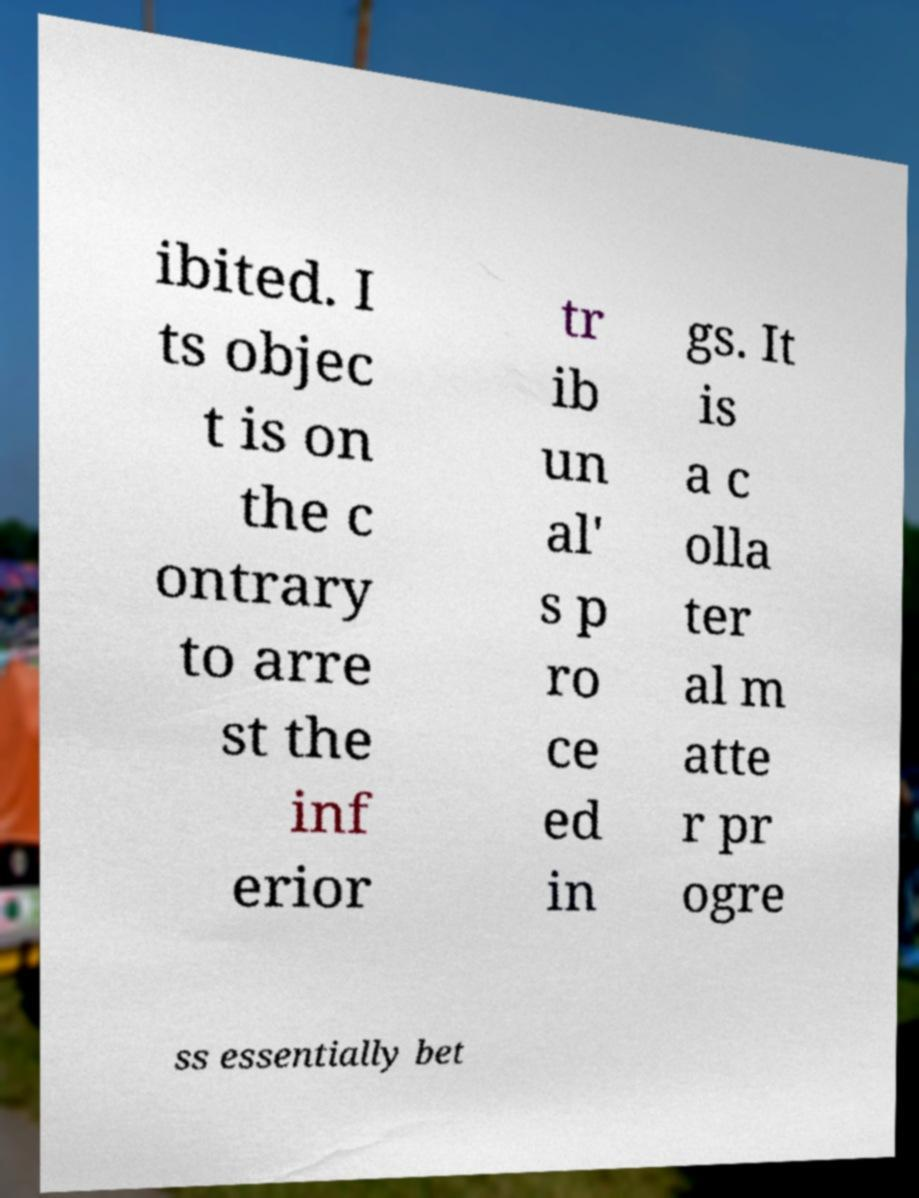For documentation purposes, I need the text within this image transcribed. Could you provide that? ibited. I ts objec t is on the c ontrary to arre st the inf erior tr ib un al' s p ro ce ed in gs. It is a c olla ter al m atte r pr ogre ss essentially bet 